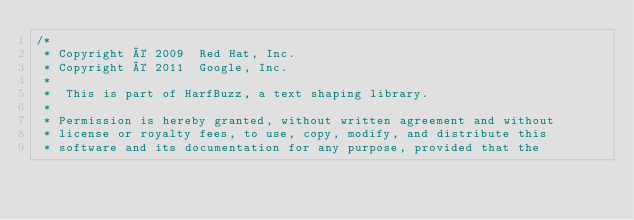Convert code to text. <code><loc_0><loc_0><loc_500><loc_500><_C++_>/*
 * Copyright © 2009  Red Hat, Inc.
 * Copyright © 2011  Google, Inc.
 *
 *  This is part of HarfBuzz, a text shaping library.
 *
 * Permission is hereby granted, without written agreement and without
 * license or royalty fees, to use, copy, modify, and distribute this
 * software and its documentation for any purpose, provided that the</code> 